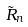Convert formula to latex. <formula><loc_0><loc_0><loc_500><loc_500>\tilde { R } _ { n }</formula> 